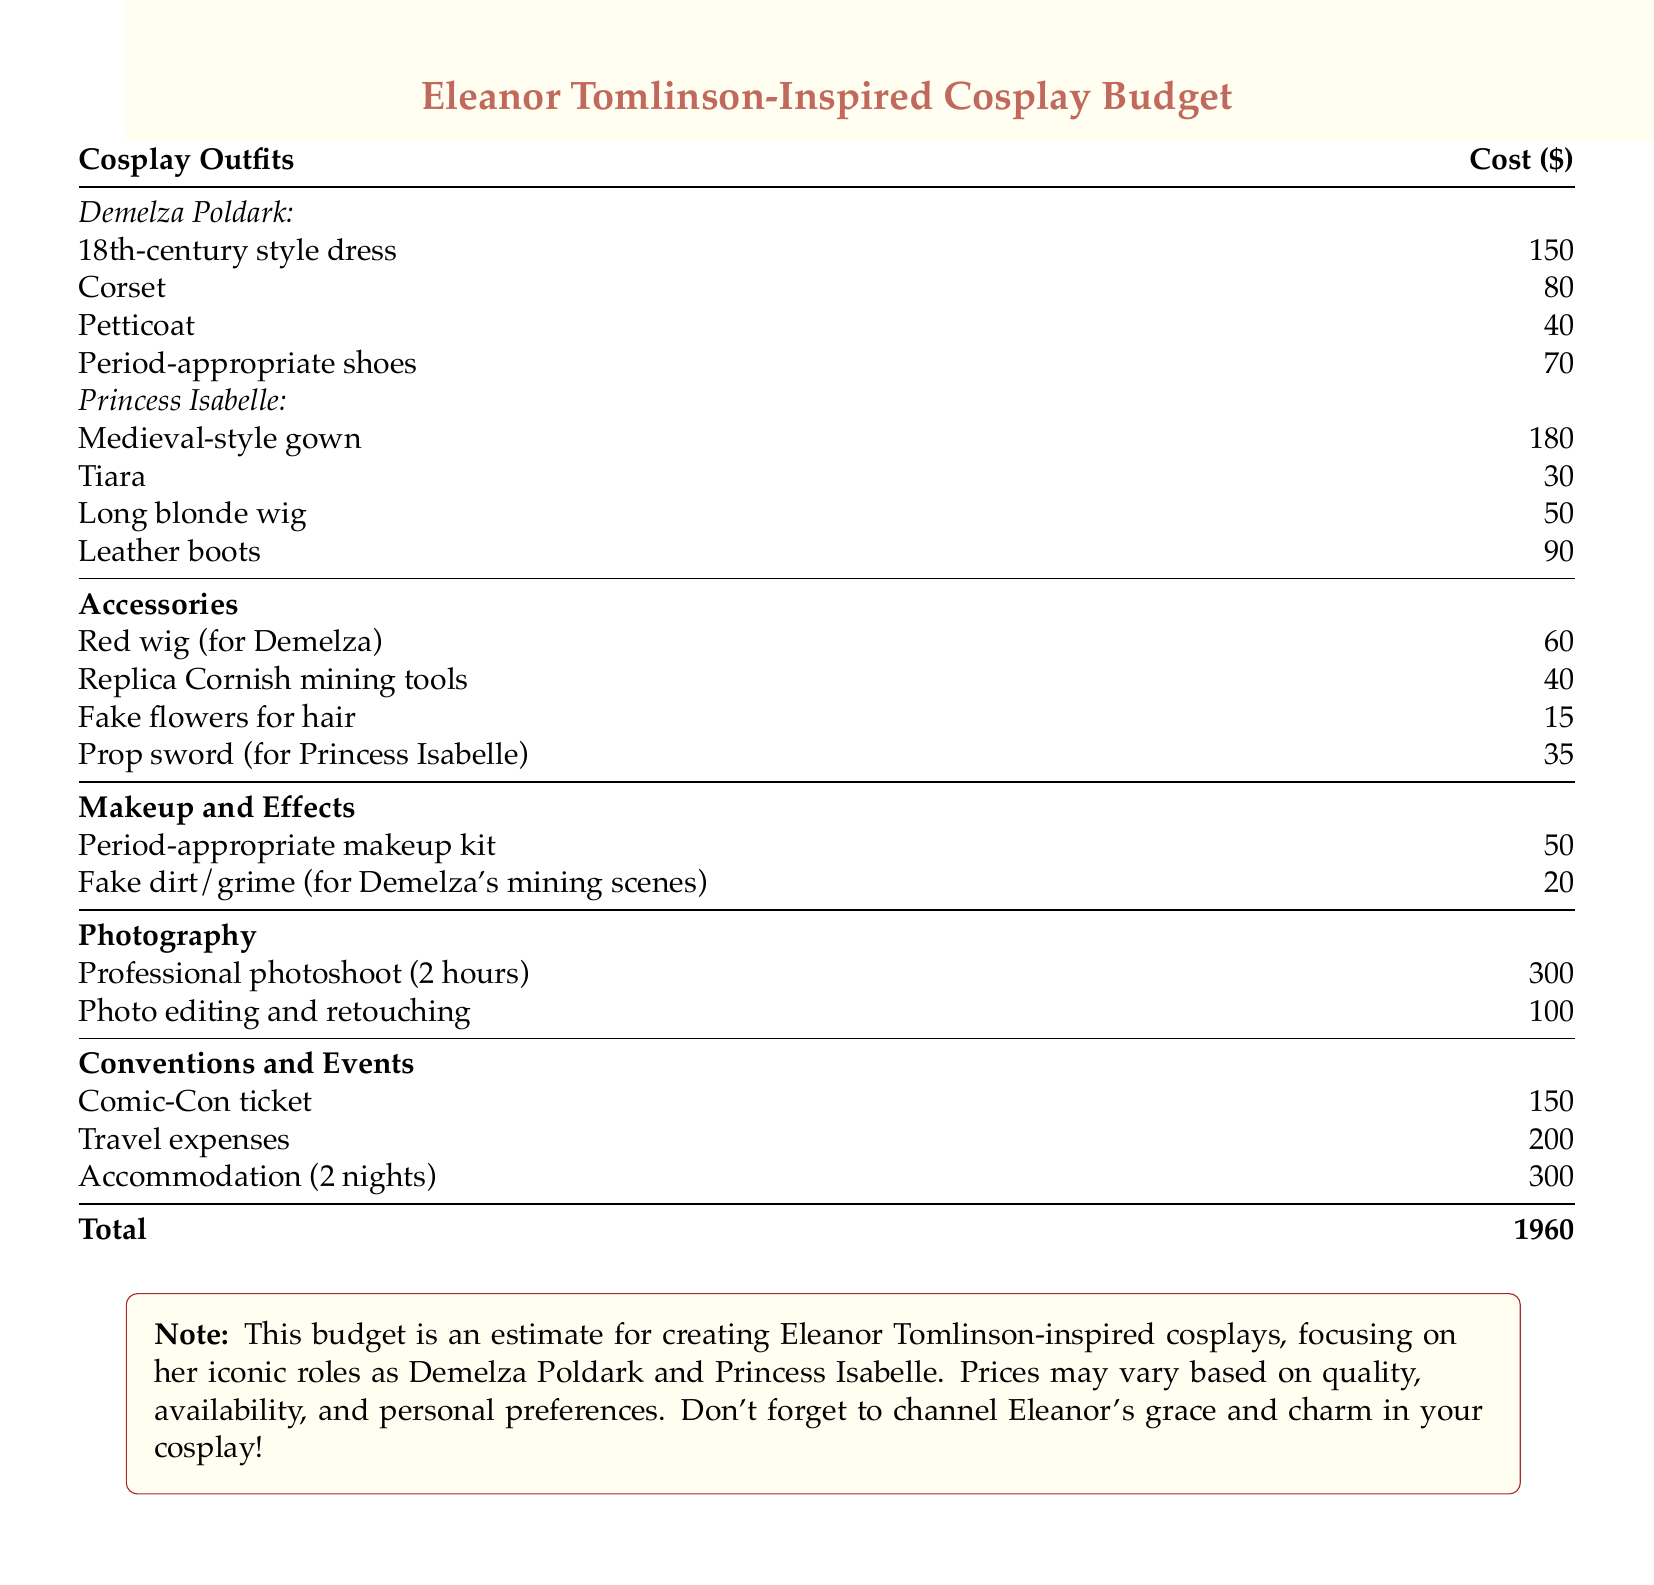What is the total cost of the cosplay budget? The total cost is listed at the bottom of the document, which totals all expenses together.
Answer: 1960 How much does the medieval-style gown cost? The cost for the medieval-style gown is specified under Princess Isabelle's cosplay section in the document.
Answer: 180 What accessory is purchased for Demelza? The document lists specific accessories that are associated with Demelza's character, including wigs and props.
Answer: Red wig What are the accommodation costs for the convention? This cost is mentioned under the conventions and events section as part of the overall expenses.
Answer: 300 How much does the professional photoshoot cost? The price of the professional photoshoot is detailed in the photography section of the budget.
Answer: 300 What is included in the Makeup and Effects category? The document specifies items that fall under the Makeup and Effects category, indicating necessary makeup products.
Answer: Period-appropriate makeup kit Which role requires a prop sword? The document attributes the prop sword to a specific role, reflecting cosplay choices for that character.
Answer: Princess Isabelle What is the cost of travel expenses listed? Travel expenses are enumerated under the conventions and events section as part of the cosplay budget.
Answer: 200 How many nights of accommodation are budgeted for? The document notes the number of nights required for accommodation during the event.
Answer: 2 nights 